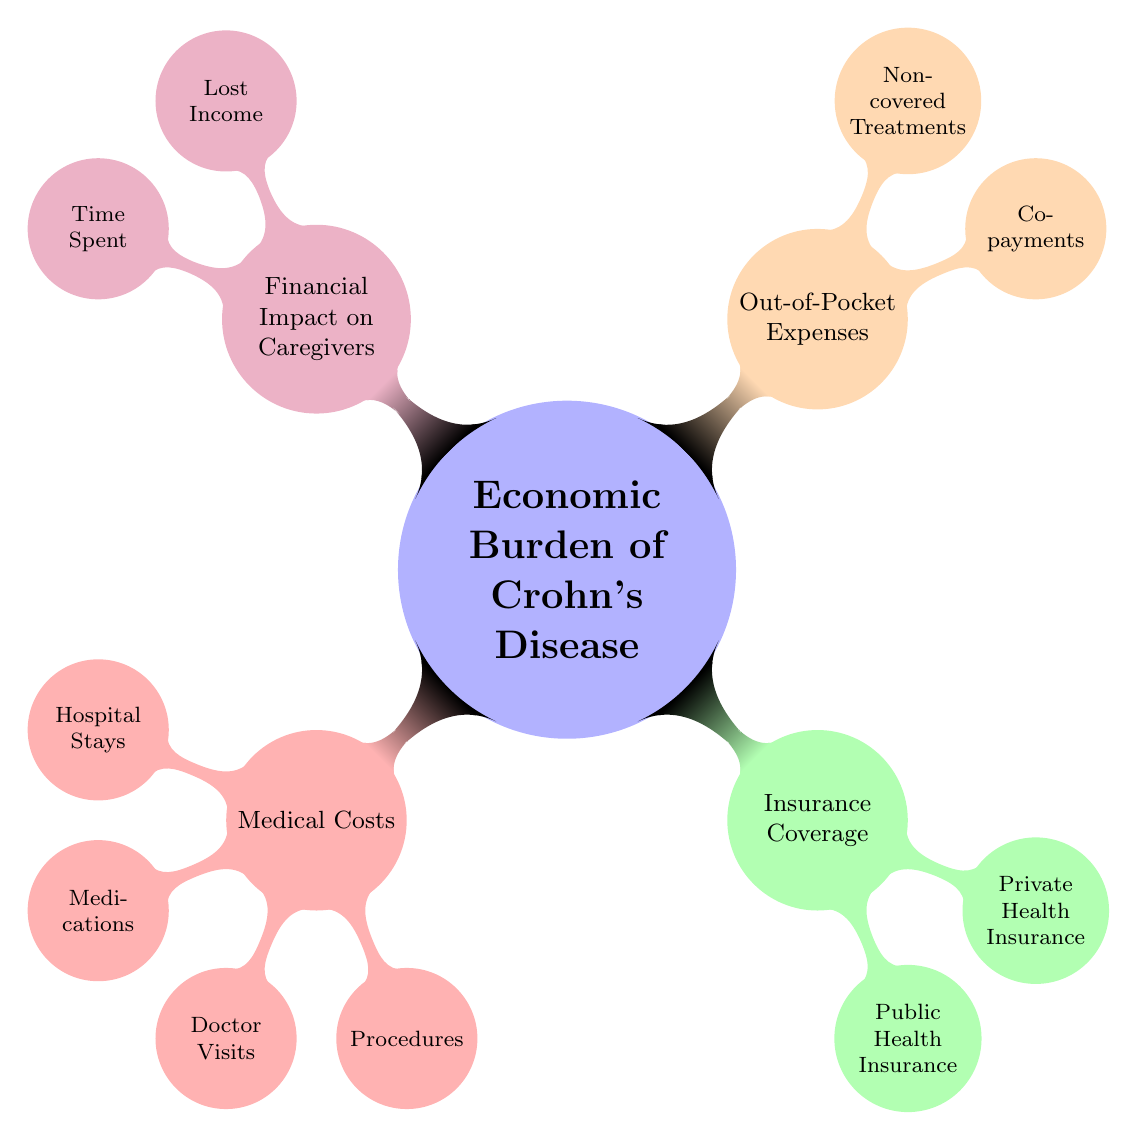What are the four main categories representing the economic burden of Crohn's disease? The diagram features four main categories: Medical Costs, Insurance Coverage, Out-of-Pocket Expenses, and Financial Impact on Caregivers. Each of these categories branches out to more specific topics, illustrating the components contributing to the economic burden.
Answer: Medical Costs, Insurance Coverage, Out-of-Pocket Expenses, Financial Impact on Caregivers What node is a child of 'Medical Costs'? The 'Medical Costs' category consists of several child nodes, including Hospital Stays, Medications, Doctor Visits, and Procedures. Choosing one of these, Hospital Stays is identified as a specific child under the broader category of Medical Costs.
Answer: Hospital Stays How many child nodes does 'Insurance Coverage' have? The 'Insurance Coverage' category includes two child nodes: Public Health Insurance and Private Health Insurance. To determine the number of child nodes, we count these two categories.
Answer: 2 What two factors are included in the 'Financial Impact on Caregivers'? In the 'Financial Impact on Caregivers', there are two pertinent child nodes: Lost Income and Time Spent. Both of these aspects highlight the economic strain on those who provide care to individuals with Crohn's disease.
Answer: Lost Income, Time Spent Which category has the most detailed breakdown of expenses? Upon analyzing the diagram, 'Medical Costs' features the most detailed breakdown, as it further includes four distinct child nodes: Hospital Stays, Medications, Doctor Visits, and Procedures, compared to other categories which have fewer subdivisions.
Answer: Medical Costs How do 'Out-of-Pocket Expenses' relate to 'Insurance Coverage'? 'Out-of-Pocket Expenses' represent costs that the patient must pay out of their own funds, which typically arise from services not fully covered by 'Insurance Coverage'. These two categories illustrate the relationship between insurance limits and personal expenditure, where high out-of-pocket expenses can indicate inadequate coverage.
Answer: Insurance Coverage What is one example of out-of-pocket expenses listed in the diagram? In the 'Out-of-Pocket Expenses' section, Co-payments is specifically mentioned as an example of personal expenses that patients might incur, highlighting an aspect of costs that are not covered by insurance.
Answer: Co-payments What color represents 'Insurance Coverage' in the diagram? In the diagram, the 'Insurance Coverage' category is represented by the color green. This distinctive coloring helps identify it quickly among the other categories, which have different colors assigned.
Answer: Green 